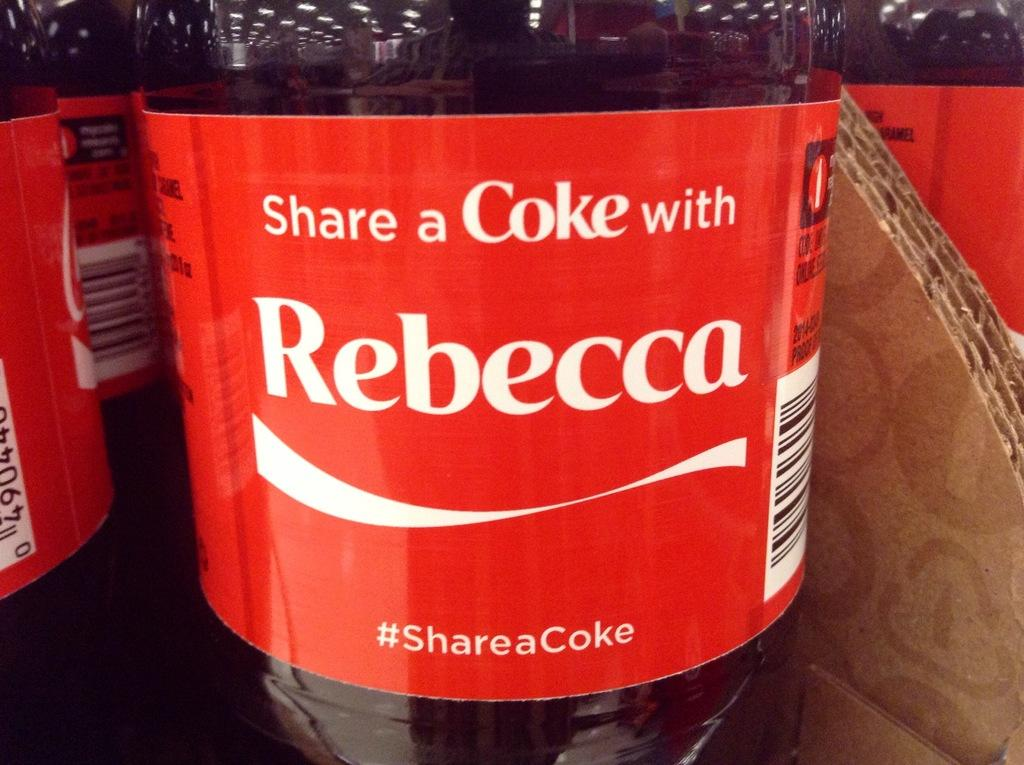Provide a one-sentence caption for the provided image. bottles of coke, front one has the name rebecca on it. 